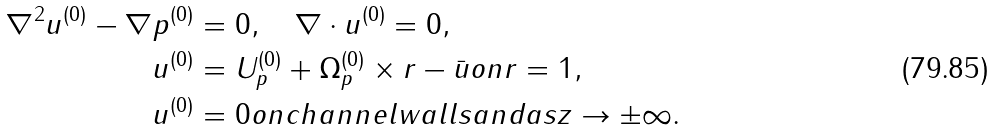Convert formula to latex. <formula><loc_0><loc_0><loc_500><loc_500>\nabla ^ { 2 } u ^ { ( 0 ) } - \nabla p ^ { ( 0 ) } & = 0 , \quad \nabla \cdot u ^ { ( 0 ) } = 0 , \\ u ^ { ( 0 ) } & = U _ { p } ^ { ( 0 ) } + \Omega _ { p } ^ { ( 0 ) } \times r - \bar { u } o n r = 1 , \\ u ^ { ( 0 ) } & = 0 o n c h a n n e l w a l l s a n d a s z \to \pm \infty .</formula> 